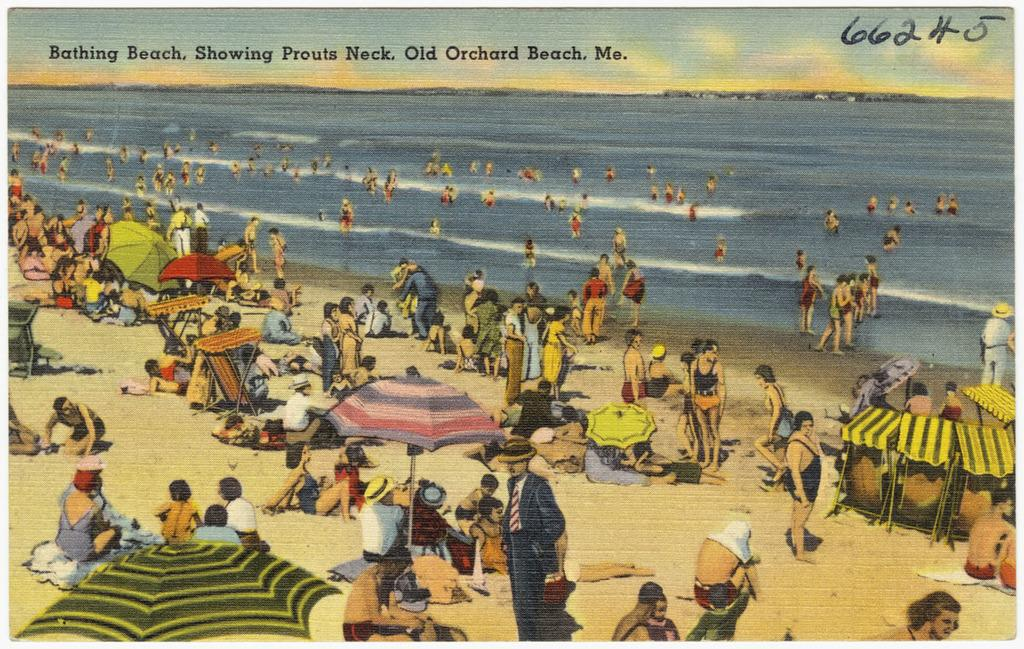<image>
Summarize the visual content of the image. A postcard with a picture of Old Orchard Beach on it. 